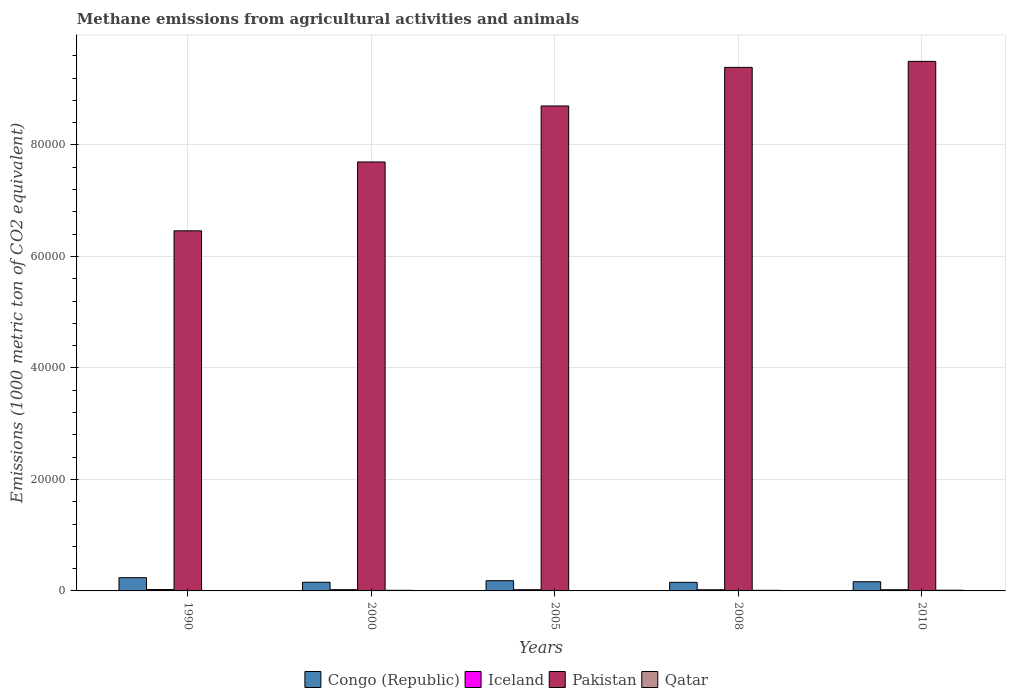How many groups of bars are there?
Keep it short and to the point. 5. Are the number of bars on each tick of the X-axis equal?
Provide a short and direct response. Yes. How many bars are there on the 2nd tick from the left?
Your response must be concise. 4. How many bars are there on the 2nd tick from the right?
Your answer should be very brief. 4. In how many cases, is the number of bars for a given year not equal to the number of legend labels?
Offer a terse response. 0. What is the amount of methane emitted in Congo (Republic) in 2005?
Your answer should be compact. 1835.4. Across all years, what is the maximum amount of methane emitted in Iceland?
Offer a very short reply. 245.3. Across all years, what is the minimum amount of methane emitted in Congo (Republic)?
Keep it short and to the point. 1535.9. In which year was the amount of methane emitted in Qatar maximum?
Give a very brief answer. 2010. What is the total amount of methane emitted in Pakistan in the graph?
Make the answer very short. 4.17e+05. What is the difference between the amount of methane emitted in Pakistan in 1990 and that in 2010?
Give a very brief answer. -3.04e+04. What is the difference between the amount of methane emitted in Pakistan in 2010 and the amount of methane emitted in Iceland in 2005?
Your answer should be compact. 9.48e+04. What is the average amount of methane emitted in Iceland per year?
Make the answer very short. 221.1. In the year 2000, what is the difference between the amount of methane emitted in Qatar and amount of methane emitted in Congo (Republic)?
Provide a succinct answer. -1441.4. What is the ratio of the amount of methane emitted in Congo (Republic) in 2005 to that in 2008?
Make the answer very short. 1.19. What is the difference between the highest and the second highest amount of methane emitted in Qatar?
Offer a terse response. 14.4. What is the difference between the highest and the lowest amount of methane emitted in Iceland?
Your response must be concise. 36.1. In how many years, is the amount of methane emitted in Pakistan greater than the average amount of methane emitted in Pakistan taken over all years?
Make the answer very short. 3. Is the sum of the amount of methane emitted in Congo (Republic) in 2005 and 2010 greater than the maximum amount of methane emitted in Pakistan across all years?
Keep it short and to the point. No. Is it the case that in every year, the sum of the amount of methane emitted in Congo (Republic) and amount of methane emitted in Pakistan is greater than the sum of amount of methane emitted in Iceland and amount of methane emitted in Qatar?
Provide a succinct answer. Yes. What does the 4th bar from the left in 2008 represents?
Offer a terse response. Qatar. What does the 1st bar from the right in 2008 represents?
Offer a very short reply. Qatar. Is it the case that in every year, the sum of the amount of methane emitted in Congo (Republic) and amount of methane emitted in Iceland is greater than the amount of methane emitted in Pakistan?
Ensure brevity in your answer.  No. How many years are there in the graph?
Your answer should be compact. 5. What is the difference between two consecutive major ticks on the Y-axis?
Keep it short and to the point. 2.00e+04. Where does the legend appear in the graph?
Keep it short and to the point. Bottom center. How many legend labels are there?
Your response must be concise. 4. How are the legend labels stacked?
Offer a terse response. Horizontal. What is the title of the graph?
Your response must be concise. Methane emissions from agricultural activities and animals. What is the label or title of the Y-axis?
Keep it short and to the point. Emissions (1000 metric ton of CO2 equivalent). What is the Emissions (1000 metric ton of CO2 equivalent) in Congo (Republic) in 1990?
Provide a succinct answer. 2369.4. What is the Emissions (1000 metric ton of CO2 equivalent) of Iceland in 1990?
Your answer should be very brief. 245.3. What is the Emissions (1000 metric ton of CO2 equivalent) in Pakistan in 1990?
Your answer should be compact. 6.46e+04. What is the Emissions (1000 metric ton of CO2 equivalent) of Qatar in 1990?
Ensure brevity in your answer.  63.8. What is the Emissions (1000 metric ton of CO2 equivalent) of Congo (Republic) in 2000?
Give a very brief answer. 1552.9. What is the Emissions (1000 metric ton of CO2 equivalent) of Iceland in 2000?
Your answer should be compact. 223.7. What is the Emissions (1000 metric ton of CO2 equivalent) in Pakistan in 2000?
Provide a succinct answer. 7.69e+04. What is the Emissions (1000 metric ton of CO2 equivalent) in Qatar in 2000?
Your answer should be compact. 111.5. What is the Emissions (1000 metric ton of CO2 equivalent) in Congo (Republic) in 2005?
Your answer should be compact. 1835.4. What is the Emissions (1000 metric ton of CO2 equivalent) in Iceland in 2005?
Provide a short and direct response. 214.9. What is the Emissions (1000 metric ton of CO2 equivalent) of Pakistan in 2005?
Provide a short and direct response. 8.70e+04. What is the Emissions (1000 metric ton of CO2 equivalent) in Qatar in 2005?
Provide a short and direct response. 67.4. What is the Emissions (1000 metric ton of CO2 equivalent) in Congo (Republic) in 2008?
Provide a succinct answer. 1535.9. What is the Emissions (1000 metric ton of CO2 equivalent) in Iceland in 2008?
Ensure brevity in your answer.  209.2. What is the Emissions (1000 metric ton of CO2 equivalent) of Pakistan in 2008?
Make the answer very short. 9.39e+04. What is the Emissions (1000 metric ton of CO2 equivalent) of Qatar in 2008?
Your answer should be very brief. 110. What is the Emissions (1000 metric ton of CO2 equivalent) of Congo (Republic) in 2010?
Your response must be concise. 1647.6. What is the Emissions (1000 metric ton of CO2 equivalent) in Iceland in 2010?
Offer a very short reply. 212.4. What is the Emissions (1000 metric ton of CO2 equivalent) of Pakistan in 2010?
Your response must be concise. 9.50e+04. What is the Emissions (1000 metric ton of CO2 equivalent) in Qatar in 2010?
Provide a short and direct response. 125.9. Across all years, what is the maximum Emissions (1000 metric ton of CO2 equivalent) of Congo (Republic)?
Keep it short and to the point. 2369.4. Across all years, what is the maximum Emissions (1000 metric ton of CO2 equivalent) in Iceland?
Provide a short and direct response. 245.3. Across all years, what is the maximum Emissions (1000 metric ton of CO2 equivalent) of Pakistan?
Your answer should be very brief. 9.50e+04. Across all years, what is the maximum Emissions (1000 metric ton of CO2 equivalent) of Qatar?
Give a very brief answer. 125.9. Across all years, what is the minimum Emissions (1000 metric ton of CO2 equivalent) in Congo (Republic)?
Your answer should be compact. 1535.9. Across all years, what is the minimum Emissions (1000 metric ton of CO2 equivalent) in Iceland?
Your response must be concise. 209.2. Across all years, what is the minimum Emissions (1000 metric ton of CO2 equivalent) of Pakistan?
Your answer should be very brief. 6.46e+04. Across all years, what is the minimum Emissions (1000 metric ton of CO2 equivalent) of Qatar?
Your answer should be very brief. 63.8. What is the total Emissions (1000 metric ton of CO2 equivalent) of Congo (Republic) in the graph?
Your answer should be very brief. 8941.2. What is the total Emissions (1000 metric ton of CO2 equivalent) of Iceland in the graph?
Provide a short and direct response. 1105.5. What is the total Emissions (1000 metric ton of CO2 equivalent) in Pakistan in the graph?
Offer a very short reply. 4.17e+05. What is the total Emissions (1000 metric ton of CO2 equivalent) of Qatar in the graph?
Offer a terse response. 478.6. What is the difference between the Emissions (1000 metric ton of CO2 equivalent) in Congo (Republic) in 1990 and that in 2000?
Your response must be concise. 816.5. What is the difference between the Emissions (1000 metric ton of CO2 equivalent) in Iceland in 1990 and that in 2000?
Keep it short and to the point. 21.6. What is the difference between the Emissions (1000 metric ton of CO2 equivalent) of Pakistan in 1990 and that in 2000?
Make the answer very short. -1.24e+04. What is the difference between the Emissions (1000 metric ton of CO2 equivalent) of Qatar in 1990 and that in 2000?
Your answer should be very brief. -47.7. What is the difference between the Emissions (1000 metric ton of CO2 equivalent) of Congo (Republic) in 1990 and that in 2005?
Provide a short and direct response. 534. What is the difference between the Emissions (1000 metric ton of CO2 equivalent) in Iceland in 1990 and that in 2005?
Ensure brevity in your answer.  30.4. What is the difference between the Emissions (1000 metric ton of CO2 equivalent) in Pakistan in 1990 and that in 2005?
Ensure brevity in your answer.  -2.24e+04. What is the difference between the Emissions (1000 metric ton of CO2 equivalent) of Qatar in 1990 and that in 2005?
Give a very brief answer. -3.6. What is the difference between the Emissions (1000 metric ton of CO2 equivalent) in Congo (Republic) in 1990 and that in 2008?
Provide a succinct answer. 833.5. What is the difference between the Emissions (1000 metric ton of CO2 equivalent) of Iceland in 1990 and that in 2008?
Ensure brevity in your answer.  36.1. What is the difference between the Emissions (1000 metric ton of CO2 equivalent) in Pakistan in 1990 and that in 2008?
Offer a very short reply. -2.93e+04. What is the difference between the Emissions (1000 metric ton of CO2 equivalent) in Qatar in 1990 and that in 2008?
Make the answer very short. -46.2. What is the difference between the Emissions (1000 metric ton of CO2 equivalent) in Congo (Republic) in 1990 and that in 2010?
Your answer should be compact. 721.8. What is the difference between the Emissions (1000 metric ton of CO2 equivalent) in Iceland in 1990 and that in 2010?
Provide a succinct answer. 32.9. What is the difference between the Emissions (1000 metric ton of CO2 equivalent) of Pakistan in 1990 and that in 2010?
Your answer should be compact. -3.04e+04. What is the difference between the Emissions (1000 metric ton of CO2 equivalent) of Qatar in 1990 and that in 2010?
Provide a short and direct response. -62.1. What is the difference between the Emissions (1000 metric ton of CO2 equivalent) in Congo (Republic) in 2000 and that in 2005?
Ensure brevity in your answer.  -282.5. What is the difference between the Emissions (1000 metric ton of CO2 equivalent) of Pakistan in 2000 and that in 2005?
Offer a terse response. -1.00e+04. What is the difference between the Emissions (1000 metric ton of CO2 equivalent) in Qatar in 2000 and that in 2005?
Ensure brevity in your answer.  44.1. What is the difference between the Emissions (1000 metric ton of CO2 equivalent) in Congo (Republic) in 2000 and that in 2008?
Ensure brevity in your answer.  17. What is the difference between the Emissions (1000 metric ton of CO2 equivalent) of Pakistan in 2000 and that in 2008?
Your response must be concise. -1.70e+04. What is the difference between the Emissions (1000 metric ton of CO2 equivalent) in Qatar in 2000 and that in 2008?
Keep it short and to the point. 1.5. What is the difference between the Emissions (1000 metric ton of CO2 equivalent) in Congo (Republic) in 2000 and that in 2010?
Your answer should be compact. -94.7. What is the difference between the Emissions (1000 metric ton of CO2 equivalent) in Iceland in 2000 and that in 2010?
Your answer should be compact. 11.3. What is the difference between the Emissions (1000 metric ton of CO2 equivalent) in Pakistan in 2000 and that in 2010?
Give a very brief answer. -1.80e+04. What is the difference between the Emissions (1000 metric ton of CO2 equivalent) of Qatar in 2000 and that in 2010?
Your answer should be compact. -14.4. What is the difference between the Emissions (1000 metric ton of CO2 equivalent) in Congo (Republic) in 2005 and that in 2008?
Give a very brief answer. 299.5. What is the difference between the Emissions (1000 metric ton of CO2 equivalent) of Iceland in 2005 and that in 2008?
Make the answer very short. 5.7. What is the difference between the Emissions (1000 metric ton of CO2 equivalent) of Pakistan in 2005 and that in 2008?
Ensure brevity in your answer.  -6920.4. What is the difference between the Emissions (1000 metric ton of CO2 equivalent) of Qatar in 2005 and that in 2008?
Your response must be concise. -42.6. What is the difference between the Emissions (1000 metric ton of CO2 equivalent) of Congo (Republic) in 2005 and that in 2010?
Ensure brevity in your answer.  187.8. What is the difference between the Emissions (1000 metric ton of CO2 equivalent) in Iceland in 2005 and that in 2010?
Offer a terse response. 2.5. What is the difference between the Emissions (1000 metric ton of CO2 equivalent) of Pakistan in 2005 and that in 2010?
Provide a short and direct response. -8002.4. What is the difference between the Emissions (1000 metric ton of CO2 equivalent) of Qatar in 2005 and that in 2010?
Provide a succinct answer. -58.5. What is the difference between the Emissions (1000 metric ton of CO2 equivalent) of Congo (Republic) in 2008 and that in 2010?
Your answer should be very brief. -111.7. What is the difference between the Emissions (1000 metric ton of CO2 equivalent) of Pakistan in 2008 and that in 2010?
Provide a succinct answer. -1082. What is the difference between the Emissions (1000 metric ton of CO2 equivalent) of Qatar in 2008 and that in 2010?
Keep it short and to the point. -15.9. What is the difference between the Emissions (1000 metric ton of CO2 equivalent) in Congo (Republic) in 1990 and the Emissions (1000 metric ton of CO2 equivalent) in Iceland in 2000?
Provide a short and direct response. 2145.7. What is the difference between the Emissions (1000 metric ton of CO2 equivalent) of Congo (Republic) in 1990 and the Emissions (1000 metric ton of CO2 equivalent) of Pakistan in 2000?
Keep it short and to the point. -7.46e+04. What is the difference between the Emissions (1000 metric ton of CO2 equivalent) of Congo (Republic) in 1990 and the Emissions (1000 metric ton of CO2 equivalent) of Qatar in 2000?
Ensure brevity in your answer.  2257.9. What is the difference between the Emissions (1000 metric ton of CO2 equivalent) in Iceland in 1990 and the Emissions (1000 metric ton of CO2 equivalent) in Pakistan in 2000?
Your answer should be very brief. -7.67e+04. What is the difference between the Emissions (1000 metric ton of CO2 equivalent) in Iceland in 1990 and the Emissions (1000 metric ton of CO2 equivalent) in Qatar in 2000?
Give a very brief answer. 133.8. What is the difference between the Emissions (1000 metric ton of CO2 equivalent) in Pakistan in 1990 and the Emissions (1000 metric ton of CO2 equivalent) in Qatar in 2000?
Your response must be concise. 6.45e+04. What is the difference between the Emissions (1000 metric ton of CO2 equivalent) in Congo (Republic) in 1990 and the Emissions (1000 metric ton of CO2 equivalent) in Iceland in 2005?
Ensure brevity in your answer.  2154.5. What is the difference between the Emissions (1000 metric ton of CO2 equivalent) in Congo (Republic) in 1990 and the Emissions (1000 metric ton of CO2 equivalent) in Pakistan in 2005?
Offer a terse response. -8.46e+04. What is the difference between the Emissions (1000 metric ton of CO2 equivalent) in Congo (Republic) in 1990 and the Emissions (1000 metric ton of CO2 equivalent) in Qatar in 2005?
Keep it short and to the point. 2302. What is the difference between the Emissions (1000 metric ton of CO2 equivalent) in Iceland in 1990 and the Emissions (1000 metric ton of CO2 equivalent) in Pakistan in 2005?
Keep it short and to the point. -8.67e+04. What is the difference between the Emissions (1000 metric ton of CO2 equivalent) in Iceland in 1990 and the Emissions (1000 metric ton of CO2 equivalent) in Qatar in 2005?
Provide a succinct answer. 177.9. What is the difference between the Emissions (1000 metric ton of CO2 equivalent) in Pakistan in 1990 and the Emissions (1000 metric ton of CO2 equivalent) in Qatar in 2005?
Ensure brevity in your answer.  6.45e+04. What is the difference between the Emissions (1000 metric ton of CO2 equivalent) in Congo (Republic) in 1990 and the Emissions (1000 metric ton of CO2 equivalent) in Iceland in 2008?
Offer a very short reply. 2160.2. What is the difference between the Emissions (1000 metric ton of CO2 equivalent) in Congo (Republic) in 1990 and the Emissions (1000 metric ton of CO2 equivalent) in Pakistan in 2008?
Your response must be concise. -9.15e+04. What is the difference between the Emissions (1000 metric ton of CO2 equivalent) of Congo (Republic) in 1990 and the Emissions (1000 metric ton of CO2 equivalent) of Qatar in 2008?
Offer a very short reply. 2259.4. What is the difference between the Emissions (1000 metric ton of CO2 equivalent) of Iceland in 1990 and the Emissions (1000 metric ton of CO2 equivalent) of Pakistan in 2008?
Your response must be concise. -9.37e+04. What is the difference between the Emissions (1000 metric ton of CO2 equivalent) in Iceland in 1990 and the Emissions (1000 metric ton of CO2 equivalent) in Qatar in 2008?
Provide a short and direct response. 135.3. What is the difference between the Emissions (1000 metric ton of CO2 equivalent) in Pakistan in 1990 and the Emissions (1000 metric ton of CO2 equivalent) in Qatar in 2008?
Offer a terse response. 6.45e+04. What is the difference between the Emissions (1000 metric ton of CO2 equivalent) of Congo (Republic) in 1990 and the Emissions (1000 metric ton of CO2 equivalent) of Iceland in 2010?
Give a very brief answer. 2157. What is the difference between the Emissions (1000 metric ton of CO2 equivalent) of Congo (Republic) in 1990 and the Emissions (1000 metric ton of CO2 equivalent) of Pakistan in 2010?
Give a very brief answer. -9.26e+04. What is the difference between the Emissions (1000 metric ton of CO2 equivalent) in Congo (Republic) in 1990 and the Emissions (1000 metric ton of CO2 equivalent) in Qatar in 2010?
Ensure brevity in your answer.  2243.5. What is the difference between the Emissions (1000 metric ton of CO2 equivalent) of Iceland in 1990 and the Emissions (1000 metric ton of CO2 equivalent) of Pakistan in 2010?
Make the answer very short. -9.47e+04. What is the difference between the Emissions (1000 metric ton of CO2 equivalent) in Iceland in 1990 and the Emissions (1000 metric ton of CO2 equivalent) in Qatar in 2010?
Provide a short and direct response. 119.4. What is the difference between the Emissions (1000 metric ton of CO2 equivalent) in Pakistan in 1990 and the Emissions (1000 metric ton of CO2 equivalent) in Qatar in 2010?
Give a very brief answer. 6.45e+04. What is the difference between the Emissions (1000 metric ton of CO2 equivalent) of Congo (Republic) in 2000 and the Emissions (1000 metric ton of CO2 equivalent) of Iceland in 2005?
Offer a very short reply. 1338. What is the difference between the Emissions (1000 metric ton of CO2 equivalent) in Congo (Republic) in 2000 and the Emissions (1000 metric ton of CO2 equivalent) in Pakistan in 2005?
Your answer should be very brief. -8.54e+04. What is the difference between the Emissions (1000 metric ton of CO2 equivalent) in Congo (Republic) in 2000 and the Emissions (1000 metric ton of CO2 equivalent) in Qatar in 2005?
Your answer should be very brief. 1485.5. What is the difference between the Emissions (1000 metric ton of CO2 equivalent) in Iceland in 2000 and the Emissions (1000 metric ton of CO2 equivalent) in Pakistan in 2005?
Provide a short and direct response. -8.68e+04. What is the difference between the Emissions (1000 metric ton of CO2 equivalent) in Iceland in 2000 and the Emissions (1000 metric ton of CO2 equivalent) in Qatar in 2005?
Give a very brief answer. 156.3. What is the difference between the Emissions (1000 metric ton of CO2 equivalent) in Pakistan in 2000 and the Emissions (1000 metric ton of CO2 equivalent) in Qatar in 2005?
Make the answer very short. 7.69e+04. What is the difference between the Emissions (1000 metric ton of CO2 equivalent) of Congo (Republic) in 2000 and the Emissions (1000 metric ton of CO2 equivalent) of Iceland in 2008?
Your response must be concise. 1343.7. What is the difference between the Emissions (1000 metric ton of CO2 equivalent) in Congo (Republic) in 2000 and the Emissions (1000 metric ton of CO2 equivalent) in Pakistan in 2008?
Offer a very short reply. -9.24e+04. What is the difference between the Emissions (1000 metric ton of CO2 equivalent) in Congo (Republic) in 2000 and the Emissions (1000 metric ton of CO2 equivalent) in Qatar in 2008?
Give a very brief answer. 1442.9. What is the difference between the Emissions (1000 metric ton of CO2 equivalent) of Iceland in 2000 and the Emissions (1000 metric ton of CO2 equivalent) of Pakistan in 2008?
Make the answer very short. -9.37e+04. What is the difference between the Emissions (1000 metric ton of CO2 equivalent) in Iceland in 2000 and the Emissions (1000 metric ton of CO2 equivalent) in Qatar in 2008?
Your answer should be very brief. 113.7. What is the difference between the Emissions (1000 metric ton of CO2 equivalent) of Pakistan in 2000 and the Emissions (1000 metric ton of CO2 equivalent) of Qatar in 2008?
Make the answer very short. 7.68e+04. What is the difference between the Emissions (1000 metric ton of CO2 equivalent) in Congo (Republic) in 2000 and the Emissions (1000 metric ton of CO2 equivalent) in Iceland in 2010?
Offer a terse response. 1340.5. What is the difference between the Emissions (1000 metric ton of CO2 equivalent) of Congo (Republic) in 2000 and the Emissions (1000 metric ton of CO2 equivalent) of Pakistan in 2010?
Offer a very short reply. -9.34e+04. What is the difference between the Emissions (1000 metric ton of CO2 equivalent) of Congo (Republic) in 2000 and the Emissions (1000 metric ton of CO2 equivalent) of Qatar in 2010?
Offer a very short reply. 1427. What is the difference between the Emissions (1000 metric ton of CO2 equivalent) of Iceland in 2000 and the Emissions (1000 metric ton of CO2 equivalent) of Pakistan in 2010?
Make the answer very short. -9.48e+04. What is the difference between the Emissions (1000 metric ton of CO2 equivalent) of Iceland in 2000 and the Emissions (1000 metric ton of CO2 equivalent) of Qatar in 2010?
Your answer should be very brief. 97.8. What is the difference between the Emissions (1000 metric ton of CO2 equivalent) in Pakistan in 2000 and the Emissions (1000 metric ton of CO2 equivalent) in Qatar in 2010?
Your answer should be very brief. 7.68e+04. What is the difference between the Emissions (1000 metric ton of CO2 equivalent) of Congo (Republic) in 2005 and the Emissions (1000 metric ton of CO2 equivalent) of Iceland in 2008?
Provide a succinct answer. 1626.2. What is the difference between the Emissions (1000 metric ton of CO2 equivalent) in Congo (Republic) in 2005 and the Emissions (1000 metric ton of CO2 equivalent) in Pakistan in 2008?
Offer a terse response. -9.21e+04. What is the difference between the Emissions (1000 metric ton of CO2 equivalent) in Congo (Republic) in 2005 and the Emissions (1000 metric ton of CO2 equivalent) in Qatar in 2008?
Your response must be concise. 1725.4. What is the difference between the Emissions (1000 metric ton of CO2 equivalent) of Iceland in 2005 and the Emissions (1000 metric ton of CO2 equivalent) of Pakistan in 2008?
Offer a very short reply. -9.37e+04. What is the difference between the Emissions (1000 metric ton of CO2 equivalent) of Iceland in 2005 and the Emissions (1000 metric ton of CO2 equivalent) of Qatar in 2008?
Provide a succinct answer. 104.9. What is the difference between the Emissions (1000 metric ton of CO2 equivalent) of Pakistan in 2005 and the Emissions (1000 metric ton of CO2 equivalent) of Qatar in 2008?
Provide a short and direct response. 8.69e+04. What is the difference between the Emissions (1000 metric ton of CO2 equivalent) of Congo (Republic) in 2005 and the Emissions (1000 metric ton of CO2 equivalent) of Iceland in 2010?
Your answer should be compact. 1623. What is the difference between the Emissions (1000 metric ton of CO2 equivalent) of Congo (Republic) in 2005 and the Emissions (1000 metric ton of CO2 equivalent) of Pakistan in 2010?
Keep it short and to the point. -9.32e+04. What is the difference between the Emissions (1000 metric ton of CO2 equivalent) in Congo (Republic) in 2005 and the Emissions (1000 metric ton of CO2 equivalent) in Qatar in 2010?
Make the answer very short. 1709.5. What is the difference between the Emissions (1000 metric ton of CO2 equivalent) of Iceland in 2005 and the Emissions (1000 metric ton of CO2 equivalent) of Pakistan in 2010?
Keep it short and to the point. -9.48e+04. What is the difference between the Emissions (1000 metric ton of CO2 equivalent) of Iceland in 2005 and the Emissions (1000 metric ton of CO2 equivalent) of Qatar in 2010?
Your response must be concise. 89. What is the difference between the Emissions (1000 metric ton of CO2 equivalent) of Pakistan in 2005 and the Emissions (1000 metric ton of CO2 equivalent) of Qatar in 2010?
Provide a short and direct response. 8.69e+04. What is the difference between the Emissions (1000 metric ton of CO2 equivalent) in Congo (Republic) in 2008 and the Emissions (1000 metric ton of CO2 equivalent) in Iceland in 2010?
Provide a short and direct response. 1323.5. What is the difference between the Emissions (1000 metric ton of CO2 equivalent) of Congo (Republic) in 2008 and the Emissions (1000 metric ton of CO2 equivalent) of Pakistan in 2010?
Ensure brevity in your answer.  -9.35e+04. What is the difference between the Emissions (1000 metric ton of CO2 equivalent) of Congo (Republic) in 2008 and the Emissions (1000 metric ton of CO2 equivalent) of Qatar in 2010?
Make the answer very short. 1410. What is the difference between the Emissions (1000 metric ton of CO2 equivalent) of Iceland in 2008 and the Emissions (1000 metric ton of CO2 equivalent) of Pakistan in 2010?
Make the answer very short. -9.48e+04. What is the difference between the Emissions (1000 metric ton of CO2 equivalent) of Iceland in 2008 and the Emissions (1000 metric ton of CO2 equivalent) of Qatar in 2010?
Keep it short and to the point. 83.3. What is the difference between the Emissions (1000 metric ton of CO2 equivalent) in Pakistan in 2008 and the Emissions (1000 metric ton of CO2 equivalent) in Qatar in 2010?
Make the answer very short. 9.38e+04. What is the average Emissions (1000 metric ton of CO2 equivalent) in Congo (Republic) per year?
Give a very brief answer. 1788.24. What is the average Emissions (1000 metric ton of CO2 equivalent) of Iceland per year?
Your response must be concise. 221.1. What is the average Emissions (1000 metric ton of CO2 equivalent) of Pakistan per year?
Offer a very short reply. 8.35e+04. What is the average Emissions (1000 metric ton of CO2 equivalent) of Qatar per year?
Make the answer very short. 95.72. In the year 1990, what is the difference between the Emissions (1000 metric ton of CO2 equivalent) in Congo (Republic) and Emissions (1000 metric ton of CO2 equivalent) in Iceland?
Provide a short and direct response. 2124.1. In the year 1990, what is the difference between the Emissions (1000 metric ton of CO2 equivalent) of Congo (Republic) and Emissions (1000 metric ton of CO2 equivalent) of Pakistan?
Provide a short and direct response. -6.22e+04. In the year 1990, what is the difference between the Emissions (1000 metric ton of CO2 equivalent) of Congo (Republic) and Emissions (1000 metric ton of CO2 equivalent) of Qatar?
Offer a very short reply. 2305.6. In the year 1990, what is the difference between the Emissions (1000 metric ton of CO2 equivalent) of Iceland and Emissions (1000 metric ton of CO2 equivalent) of Pakistan?
Offer a very short reply. -6.43e+04. In the year 1990, what is the difference between the Emissions (1000 metric ton of CO2 equivalent) of Iceland and Emissions (1000 metric ton of CO2 equivalent) of Qatar?
Provide a short and direct response. 181.5. In the year 1990, what is the difference between the Emissions (1000 metric ton of CO2 equivalent) of Pakistan and Emissions (1000 metric ton of CO2 equivalent) of Qatar?
Ensure brevity in your answer.  6.45e+04. In the year 2000, what is the difference between the Emissions (1000 metric ton of CO2 equivalent) of Congo (Republic) and Emissions (1000 metric ton of CO2 equivalent) of Iceland?
Keep it short and to the point. 1329.2. In the year 2000, what is the difference between the Emissions (1000 metric ton of CO2 equivalent) of Congo (Republic) and Emissions (1000 metric ton of CO2 equivalent) of Pakistan?
Give a very brief answer. -7.54e+04. In the year 2000, what is the difference between the Emissions (1000 metric ton of CO2 equivalent) in Congo (Republic) and Emissions (1000 metric ton of CO2 equivalent) in Qatar?
Offer a terse response. 1441.4. In the year 2000, what is the difference between the Emissions (1000 metric ton of CO2 equivalent) of Iceland and Emissions (1000 metric ton of CO2 equivalent) of Pakistan?
Offer a terse response. -7.67e+04. In the year 2000, what is the difference between the Emissions (1000 metric ton of CO2 equivalent) of Iceland and Emissions (1000 metric ton of CO2 equivalent) of Qatar?
Ensure brevity in your answer.  112.2. In the year 2000, what is the difference between the Emissions (1000 metric ton of CO2 equivalent) in Pakistan and Emissions (1000 metric ton of CO2 equivalent) in Qatar?
Your answer should be compact. 7.68e+04. In the year 2005, what is the difference between the Emissions (1000 metric ton of CO2 equivalent) in Congo (Republic) and Emissions (1000 metric ton of CO2 equivalent) in Iceland?
Make the answer very short. 1620.5. In the year 2005, what is the difference between the Emissions (1000 metric ton of CO2 equivalent) in Congo (Republic) and Emissions (1000 metric ton of CO2 equivalent) in Pakistan?
Your answer should be compact. -8.52e+04. In the year 2005, what is the difference between the Emissions (1000 metric ton of CO2 equivalent) of Congo (Republic) and Emissions (1000 metric ton of CO2 equivalent) of Qatar?
Offer a terse response. 1768. In the year 2005, what is the difference between the Emissions (1000 metric ton of CO2 equivalent) in Iceland and Emissions (1000 metric ton of CO2 equivalent) in Pakistan?
Your answer should be compact. -8.68e+04. In the year 2005, what is the difference between the Emissions (1000 metric ton of CO2 equivalent) in Iceland and Emissions (1000 metric ton of CO2 equivalent) in Qatar?
Give a very brief answer. 147.5. In the year 2005, what is the difference between the Emissions (1000 metric ton of CO2 equivalent) in Pakistan and Emissions (1000 metric ton of CO2 equivalent) in Qatar?
Give a very brief answer. 8.69e+04. In the year 2008, what is the difference between the Emissions (1000 metric ton of CO2 equivalent) in Congo (Republic) and Emissions (1000 metric ton of CO2 equivalent) in Iceland?
Your answer should be very brief. 1326.7. In the year 2008, what is the difference between the Emissions (1000 metric ton of CO2 equivalent) in Congo (Republic) and Emissions (1000 metric ton of CO2 equivalent) in Pakistan?
Ensure brevity in your answer.  -9.24e+04. In the year 2008, what is the difference between the Emissions (1000 metric ton of CO2 equivalent) of Congo (Republic) and Emissions (1000 metric ton of CO2 equivalent) of Qatar?
Provide a succinct answer. 1425.9. In the year 2008, what is the difference between the Emissions (1000 metric ton of CO2 equivalent) of Iceland and Emissions (1000 metric ton of CO2 equivalent) of Pakistan?
Your response must be concise. -9.37e+04. In the year 2008, what is the difference between the Emissions (1000 metric ton of CO2 equivalent) in Iceland and Emissions (1000 metric ton of CO2 equivalent) in Qatar?
Ensure brevity in your answer.  99.2. In the year 2008, what is the difference between the Emissions (1000 metric ton of CO2 equivalent) of Pakistan and Emissions (1000 metric ton of CO2 equivalent) of Qatar?
Provide a succinct answer. 9.38e+04. In the year 2010, what is the difference between the Emissions (1000 metric ton of CO2 equivalent) in Congo (Republic) and Emissions (1000 metric ton of CO2 equivalent) in Iceland?
Your response must be concise. 1435.2. In the year 2010, what is the difference between the Emissions (1000 metric ton of CO2 equivalent) in Congo (Republic) and Emissions (1000 metric ton of CO2 equivalent) in Pakistan?
Keep it short and to the point. -9.33e+04. In the year 2010, what is the difference between the Emissions (1000 metric ton of CO2 equivalent) in Congo (Republic) and Emissions (1000 metric ton of CO2 equivalent) in Qatar?
Offer a terse response. 1521.7. In the year 2010, what is the difference between the Emissions (1000 metric ton of CO2 equivalent) in Iceland and Emissions (1000 metric ton of CO2 equivalent) in Pakistan?
Keep it short and to the point. -9.48e+04. In the year 2010, what is the difference between the Emissions (1000 metric ton of CO2 equivalent) in Iceland and Emissions (1000 metric ton of CO2 equivalent) in Qatar?
Ensure brevity in your answer.  86.5. In the year 2010, what is the difference between the Emissions (1000 metric ton of CO2 equivalent) in Pakistan and Emissions (1000 metric ton of CO2 equivalent) in Qatar?
Provide a short and direct response. 9.49e+04. What is the ratio of the Emissions (1000 metric ton of CO2 equivalent) in Congo (Republic) in 1990 to that in 2000?
Provide a succinct answer. 1.53. What is the ratio of the Emissions (1000 metric ton of CO2 equivalent) in Iceland in 1990 to that in 2000?
Give a very brief answer. 1.1. What is the ratio of the Emissions (1000 metric ton of CO2 equivalent) of Pakistan in 1990 to that in 2000?
Your response must be concise. 0.84. What is the ratio of the Emissions (1000 metric ton of CO2 equivalent) in Qatar in 1990 to that in 2000?
Your answer should be very brief. 0.57. What is the ratio of the Emissions (1000 metric ton of CO2 equivalent) of Congo (Republic) in 1990 to that in 2005?
Make the answer very short. 1.29. What is the ratio of the Emissions (1000 metric ton of CO2 equivalent) of Iceland in 1990 to that in 2005?
Your response must be concise. 1.14. What is the ratio of the Emissions (1000 metric ton of CO2 equivalent) in Pakistan in 1990 to that in 2005?
Provide a succinct answer. 0.74. What is the ratio of the Emissions (1000 metric ton of CO2 equivalent) of Qatar in 1990 to that in 2005?
Ensure brevity in your answer.  0.95. What is the ratio of the Emissions (1000 metric ton of CO2 equivalent) in Congo (Republic) in 1990 to that in 2008?
Make the answer very short. 1.54. What is the ratio of the Emissions (1000 metric ton of CO2 equivalent) in Iceland in 1990 to that in 2008?
Provide a short and direct response. 1.17. What is the ratio of the Emissions (1000 metric ton of CO2 equivalent) of Pakistan in 1990 to that in 2008?
Offer a very short reply. 0.69. What is the ratio of the Emissions (1000 metric ton of CO2 equivalent) of Qatar in 1990 to that in 2008?
Your answer should be very brief. 0.58. What is the ratio of the Emissions (1000 metric ton of CO2 equivalent) of Congo (Republic) in 1990 to that in 2010?
Offer a very short reply. 1.44. What is the ratio of the Emissions (1000 metric ton of CO2 equivalent) in Iceland in 1990 to that in 2010?
Your answer should be very brief. 1.15. What is the ratio of the Emissions (1000 metric ton of CO2 equivalent) of Pakistan in 1990 to that in 2010?
Offer a terse response. 0.68. What is the ratio of the Emissions (1000 metric ton of CO2 equivalent) in Qatar in 1990 to that in 2010?
Your answer should be compact. 0.51. What is the ratio of the Emissions (1000 metric ton of CO2 equivalent) of Congo (Republic) in 2000 to that in 2005?
Your response must be concise. 0.85. What is the ratio of the Emissions (1000 metric ton of CO2 equivalent) of Iceland in 2000 to that in 2005?
Your answer should be compact. 1.04. What is the ratio of the Emissions (1000 metric ton of CO2 equivalent) in Pakistan in 2000 to that in 2005?
Offer a terse response. 0.88. What is the ratio of the Emissions (1000 metric ton of CO2 equivalent) of Qatar in 2000 to that in 2005?
Provide a succinct answer. 1.65. What is the ratio of the Emissions (1000 metric ton of CO2 equivalent) in Congo (Republic) in 2000 to that in 2008?
Offer a very short reply. 1.01. What is the ratio of the Emissions (1000 metric ton of CO2 equivalent) in Iceland in 2000 to that in 2008?
Make the answer very short. 1.07. What is the ratio of the Emissions (1000 metric ton of CO2 equivalent) of Pakistan in 2000 to that in 2008?
Keep it short and to the point. 0.82. What is the ratio of the Emissions (1000 metric ton of CO2 equivalent) of Qatar in 2000 to that in 2008?
Make the answer very short. 1.01. What is the ratio of the Emissions (1000 metric ton of CO2 equivalent) of Congo (Republic) in 2000 to that in 2010?
Ensure brevity in your answer.  0.94. What is the ratio of the Emissions (1000 metric ton of CO2 equivalent) of Iceland in 2000 to that in 2010?
Provide a succinct answer. 1.05. What is the ratio of the Emissions (1000 metric ton of CO2 equivalent) in Pakistan in 2000 to that in 2010?
Your response must be concise. 0.81. What is the ratio of the Emissions (1000 metric ton of CO2 equivalent) of Qatar in 2000 to that in 2010?
Make the answer very short. 0.89. What is the ratio of the Emissions (1000 metric ton of CO2 equivalent) of Congo (Republic) in 2005 to that in 2008?
Your answer should be very brief. 1.2. What is the ratio of the Emissions (1000 metric ton of CO2 equivalent) of Iceland in 2005 to that in 2008?
Offer a very short reply. 1.03. What is the ratio of the Emissions (1000 metric ton of CO2 equivalent) of Pakistan in 2005 to that in 2008?
Give a very brief answer. 0.93. What is the ratio of the Emissions (1000 metric ton of CO2 equivalent) in Qatar in 2005 to that in 2008?
Your response must be concise. 0.61. What is the ratio of the Emissions (1000 metric ton of CO2 equivalent) in Congo (Republic) in 2005 to that in 2010?
Offer a very short reply. 1.11. What is the ratio of the Emissions (1000 metric ton of CO2 equivalent) of Iceland in 2005 to that in 2010?
Ensure brevity in your answer.  1.01. What is the ratio of the Emissions (1000 metric ton of CO2 equivalent) of Pakistan in 2005 to that in 2010?
Offer a terse response. 0.92. What is the ratio of the Emissions (1000 metric ton of CO2 equivalent) of Qatar in 2005 to that in 2010?
Your response must be concise. 0.54. What is the ratio of the Emissions (1000 metric ton of CO2 equivalent) in Congo (Republic) in 2008 to that in 2010?
Make the answer very short. 0.93. What is the ratio of the Emissions (1000 metric ton of CO2 equivalent) in Iceland in 2008 to that in 2010?
Ensure brevity in your answer.  0.98. What is the ratio of the Emissions (1000 metric ton of CO2 equivalent) of Qatar in 2008 to that in 2010?
Provide a succinct answer. 0.87. What is the difference between the highest and the second highest Emissions (1000 metric ton of CO2 equivalent) of Congo (Republic)?
Provide a succinct answer. 534. What is the difference between the highest and the second highest Emissions (1000 metric ton of CO2 equivalent) of Iceland?
Offer a terse response. 21.6. What is the difference between the highest and the second highest Emissions (1000 metric ton of CO2 equivalent) in Pakistan?
Provide a succinct answer. 1082. What is the difference between the highest and the lowest Emissions (1000 metric ton of CO2 equivalent) of Congo (Republic)?
Your answer should be compact. 833.5. What is the difference between the highest and the lowest Emissions (1000 metric ton of CO2 equivalent) of Iceland?
Provide a succinct answer. 36.1. What is the difference between the highest and the lowest Emissions (1000 metric ton of CO2 equivalent) in Pakistan?
Provide a succinct answer. 3.04e+04. What is the difference between the highest and the lowest Emissions (1000 metric ton of CO2 equivalent) in Qatar?
Your answer should be very brief. 62.1. 